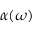<formula> <loc_0><loc_0><loc_500><loc_500>\alpha ( \omega )</formula> 